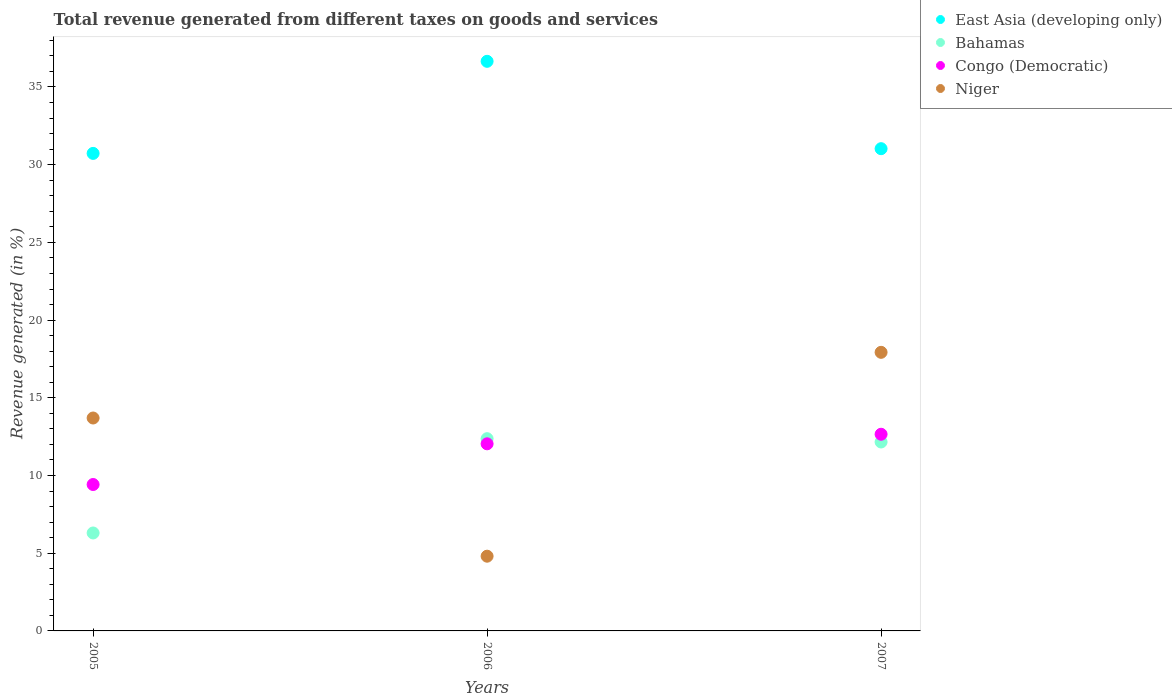What is the total revenue generated in Congo (Democratic) in 2005?
Make the answer very short. 9.42. Across all years, what is the maximum total revenue generated in Congo (Democratic)?
Offer a terse response. 12.66. Across all years, what is the minimum total revenue generated in East Asia (developing only)?
Ensure brevity in your answer.  30.73. In which year was the total revenue generated in East Asia (developing only) maximum?
Keep it short and to the point. 2006. In which year was the total revenue generated in Niger minimum?
Offer a terse response. 2006. What is the total total revenue generated in Congo (Democratic) in the graph?
Your response must be concise. 34.12. What is the difference between the total revenue generated in East Asia (developing only) in 2005 and that in 2006?
Offer a terse response. -5.92. What is the difference between the total revenue generated in Congo (Democratic) in 2006 and the total revenue generated in East Asia (developing only) in 2005?
Give a very brief answer. -18.69. What is the average total revenue generated in Bahamas per year?
Keep it short and to the point. 10.28. In the year 2005, what is the difference between the total revenue generated in East Asia (developing only) and total revenue generated in Niger?
Ensure brevity in your answer.  17.03. What is the ratio of the total revenue generated in Bahamas in 2005 to that in 2006?
Offer a very short reply. 0.51. Is the total revenue generated in Niger in 2005 less than that in 2006?
Provide a short and direct response. No. Is the difference between the total revenue generated in East Asia (developing only) in 2005 and 2007 greater than the difference between the total revenue generated in Niger in 2005 and 2007?
Provide a short and direct response. Yes. What is the difference between the highest and the second highest total revenue generated in East Asia (developing only)?
Provide a succinct answer. 5.62. What is the difference between the highest and the lowest total revenue generated in Congo (Democratic)?
Ensure brevity in your answer.  3.23. Is it the case that in every year, the sum of the total revenue generated in Congo (Democratic) and total revenue generated in East Asia (developing only)  is greater than the total revenue generated in Niger?
Offer a terse response. Yes. Is the total revenue generated in Bahamas strictly less than the total revenue generated in Congo (Democratic) over the years?
Give a very brief answer. No. How many years are there in the graph?
Your response must be concise. 3. What is the difference between two consecutive major ticks on the Y-axis?
Your answer should be compact. 5. How are the legend labels stacked?
Your response must be concise. Vertical. What is the title of the graph?
Offer a very short reply. Total revenue generated from different taxes on goods and services. Does "Puerto Rico" appear as one of the legend labels in the graph?
Ensure brevity in your answer.  No. What is the label or title of the X-axis?
Provide a succinct answer. Years. What is the label or title of the Y-axis?
Provide a succinct answer. Revenue generated (in %). What is the Revenue generated (in %) of East Asia (developing only) in 2005?
Give a very brief answer. 30.73. What is the Revenue generated (in %) in Bahamas in 2005?
Provide a succinct answer. 6.3. What is the Revenue generated (in %) in Congo (Democratic) in 2005?
Your answer should be very brief. 9.42. What is the Revenue generated (in %) in Niger in 2005?
Ensure brevity in your answer.  13.7. What is the Revenue generated (in %) of East Asia (developing only) in 2006?
Give a very brief answer. 36.65. What is the Revenue generated (in %) of Bahamas in 2006?
Your answer should be very brief. 12.37. What is the Revenue generated (in %) in Congo (Democratic) in 2006?
Offer a terse response. 12.04. What is the Revenue generated (in %) of Niger in 2006?
Your answer should be compact. 4.81. What is the Revenue generated (in %) of East Asia (developing only) in 2007?
Offer a very short reply. 31.03. What is the Revenue generated (in %) of Bahamas in 2007?
Offer a very short reply. 12.16. What is the Revenue generated (in %) in Congo (Democratic) in 2007?
Make the answer very short. 12.66. What is the Revenue generated (in %) in Niger in 2007?
Your response must be concise. 17.93. Across all years, what is the maximum Revenue generated (in %) of East Asia (developing only)?
Ensure brevity in your answer.  36.65. Across all years, what is the maximum Revenue generated (in %) in Bahamas?
Ensure brevity in your answer.  12.37. Across all years, what is the maximum Revenue generated (in %) of Congo (Democratic)?
Ensure brevity in your answer.  12.66. Across all years, what is the maximum Revenue generated (in %) in Niger?
Provide a short and direct response. 17.93. Across all years, what is the minimum Revenue generated (in %) in East Asia (developing only)?
Ensure brevity in your answer.  30.73. Across all years, what is the minimum Revenue generated (in %) in Bahamas?
Your response must be concise. 6.3. Across all years, what is the minimum Revenue generated (in %) in Congo (Democratic)?
Provide a succinct answer. 9.42. Across all years, what is the minimum Revenue generated (in %) of Niger?
Your answer should be very brief. 4.81. What is the total Revenue generated (in %) of East Asia (developing only) in the graph?
Your answer should be compact. 98.41. What is the total Revenue generated (in %) of Bahamas in the graph?
Your answer should be very brief. 30.83. What is the total Revenue generated (in %) of Congo (Democratic) in the graph?
Provide a succinct answer. 34.12. What is the total Revenue generated (in %) in Niger in the graph?
Keep it short and to the point. 36.44. What is the difference between the Revenue generated (in %) in East Asia (developing only) in 2005 and that in 2006?
Provide a succinct answer. -5.92. What is the difference between the Revenue generated (in %) in Bahamas in 2005 and that in 2006?
Offer a terse response. -6.07. What is the difference between the Revenue generated (in %) in Congo (Democratic) in 2005 and that in 2006?
Your answer should be compact. -2.62. What is the difference between the Revenue generated (in %) of Niger in 2005 and that in 2006?
Ensure brevity in your answer.  8.89. What is the difference between the Revenue generated (in %) of East Asia (developing only) in 2005 and that in 2007?
Your answer should be very brief. -0.3. What is the difference between the Revenue generated (in %) of Bahamas in 2005 and that in 2007?
Provide a short and direct response. -5.85. What is the difference between the Revenue generated (in %) of Congo (Democratic) in 2005 and that in 2007?
Your answer should be very brief. -3.23. What is the difference between the Revenue generated (in %) in Niger in 2005 and that in 2007?
Provide a short and direct response. -4.23. What is the difference between the Revenue generated (in %) of East Asia (developing only) in 2006 and that in 2007?
Offer a terse response. 5.62. What is the difference between the Revenue generated (in %) in Bahamas in 2006 and that in 2007?
Your answer should be compact. 0.21. What is the difference between the Revenue generated (in %) of Congo (Democratic) in 2006 and that in 2007?
Your answer should be very brief. -0.62. What is the difference between the Revenue generated (in %) of Niger in 2006 and that in 2007?
Your answer should be compact. -13.12. What is the difference between the Revenue generated (in %) in East Asia (developing only) in 2005 and the Revenue generated (in %) in Bahamas in 2006?
Keep it short and to the point. 18.36. What is the difference between the Revenue generated (in %) in East Asia (developing only) in 2005 and the Revenue generated (in %) in Congo (Democratic) in 2006?
Offer a very short reply. 18.69. What is the difference between the Revenue generated (in %) in East Asia (developing only) in 2005 and the Revenue generated (in %) in Niger in 2006?
Make the answer very short. 25.92. What is the difference between the Revenue generated (in %) in Bahamas in 2005 and the Revenue generated (in %) in Congo (Democratic) in 2006?
Your response must be concise. -5.74. What is the difference between the Revenue generated (in %) in Bahamas in 2005 and the Revenue generated (in %) in Niger in 2006?
Your answer should be compact. 1.49. What is the difference between the Revenue generated (in %) in Congo (Democratic) in 2005 and the Revenue generated (in %) in Niger in 2006?
Provide a succinct answer. 4.61. What is the difference between the Revenue generated (in %) of East Asia (developing only) in 2005 and the Revenue generated (in %) of Bahamas in 2007?
Keep it short and to the point. 18.57. What is the difference between the Revenue generated (in %) of East Asia (developing only) in 2005 and the Revenue generated (in %) of Congo (Democratic) in 2007?
Give a very brief answer. 18.07. What is the difference between the Revenue generated (in %) of East Asia (developing only) in 2005 and the Revenue generated (in %) of Niger in 2007?
Your answer should be compact. 12.8. What is the difference between the Revenue generated (in %) of Bahamas in 2005 and the Revenue generated (in %) of Congo (Democratic) in 2007?
Offer a terse response. -6.35. What is the difference between the Revenue generated (in %) in Bahamas in 2005 and the Revenue generated (in %) in Niger in 2007?
Give a very brief answer. -11.62. What is the difference between the Revenue generated (in %) of Congo (Democratic) in 2005 and the Revenue generated (in %) of Niger in 2007?
Provide a succinct answer. -8.51. What is the difference between the Revenue generated (in %) in East Asia (developing only) in 2006 and the Revenue generated (in %) in Bahamas in 2007?
Keep it short and to the point. 24.5. What is the difference between the Revenue generated (in %) of East Asia (developing only) in 2006 and the Revenue generated (in %) of Congo (Democratic) in 2007?
Your answer should be very brief. 24. What is the difference between the Revenue generated (in %) in East Asia (developing only) in 2006 and the Revenue generated (in %) in Niger in 2007?
Provide a short and direct response. 18.73. What is the difference between the Revenue generated (in %) of Bahamas in 2006 and the Revenue generated (in %) of Congo (Democratic) in 2007?
Offer a terse response. -0.29. What is the difference between the Revenue generated (in %) in Bahamas in 2006 and the Revenue generated (in %) in Niger in 2007?
Give a very brief answer. -5.56. What is the difference between the Revenue generated (in %) in Congo (Democratic) in 2006 and the Revenue generated (in %) in Niger in 2007?
Make the answer very short. -5.89. What is the average Revenue generated (in %) in East Asia (developing only) per year?
Make the answer very short. 32.8. What is the average Revenue generated (in %) in Bahamas per year?
Your response must be concise. 10.28. What is the average Revenue generated (in %) of Congo (Democratic) per year?
Your response must be concise. 11.37. What is the average Revenue generated (in %) of Niger per year?
Your response must be concise. 12.15. In the year 2005, what is the difference between the Revenue generated (in %) in East Asia (developing only) and Revenue generated (in %) in Bahamas?
Your answer should be compact. 24.42. In the year 2005, what is the difference between the Revenue generated (in %) of East Asia (developing only) and Revenue generated (in %) of Congo (Democratic)?
Give a very brief answer. 21.31. In the year 2005, what is the difference between the Revenue generated (in %) in East Asia (developing only) and Revenue generated (in %) in Niger?
Give a very brief answer. 17.03. In the year 2005, what is the difference between the Revenue generated (in %) of Bahamas and Revenue generated (in %) of Congo (Democratic)?
Offer a very short reply. -3.12. In the year 2005, what is the difference between the Revenue generated (in %) in Bahamas and Revenue generated (in %) in Niger?
Your response must be concise. -7.4. In the year 2005, what is the difference between the Revenue generated (in %) in Congo (Democratic) and Revenue generated (in %) in Niger?
Give a very brief answer. -4.28. In the year 2006, what is the difference between the Revenue generated (in %) in East Asia (developing only) and Revenue generated (in %) in Bahamas?
Keep it short and to the point. 24.28. In the year 2006, what is the difference between the Revenue generated (in %) of East Asia (developing only) and Revenue generated (in %) of Congo (Democratic)?
Provide a short and direct response. 24.61. In the year 2006, what is the difference between the Revenue generated (in %) in East Asia (developing only) and Revenue generated (in %) in Niger?
Keep it short and to the point. 31.84. In the year 2006, what is the difference between the Revenue generated (in %) in Bahamas and Revenue generated (in %) in Congo (Democratic)?
Your response must be concise. 0.33. In the year 2006, what is the difference between the Revenue generated (in %) in Bahamas and Revenue generated (in %) in Niger?
Offer a terse response. 7.56. In the year 2006, what is the difference between the Revenue generated (in %) of Congo (Democratic) and Revenue generated (in %) of Niger?
Your answer should be very brief. 7.23. In the year 2007, what is the difference between the Revenue generated (in %) of East Asia (developing only) and Revenue generated (in %) of Bahamas?
Offer a terse response. 18.87. In the year 2007, what is the difference between the Revenue generated (in %) in East Asia (developing only) and Revenue generated (in %) in Congo (Democratic)?
Your response must be concise. 18.38. In the year 2007, what is the difference between the Revenue generated (in %) in East Asia (developing only) and Revenue generated (in %) in Niger?
Give a very brief answer. 13.1. In the year 2007, what is the difference between the Revenue generated (in %) in Bahamas and Revenue generated (in %) in Congo (Democratic)?
Ensure brevity in your answer.  -0.5. In the year 2007, what is the difference between the Revenue generated (in %) in Bahamas and Revenue generated (in %) in Niger?
Offer a very short reply. -5.77. In the year 2007, what is the difference between the Revenue generated (in %) of Congo (Democratic) and Revenue generated (in %) of Niger?
Give a very brief answer. -5.27. What is the ratio of the Revenue generated (in %) in East Asia (developing only) in 2005 to that in 2006?
Your answer should be compact. 0.84. What is the ratio of the Revenue generated (in %) in Bahamas in 2005 to that in 2006?
Your answer should be compact. 0.51. What is the ratio of the Revenue generated (in %) in Congo (Democratic) in 2005 to that in 2006?
Ensure brevity in your answer.  0.78. What is the ratio of the Revenue generated (in %) of Niger in 2005 to that in 2006?
Your answer should be compact. 2.85. What is the ratio of the Revenue generated (in %) of East Asia (developing only) in 2005 to that in 2007?
Keep it short and to the point. 0.99. What is the ratio of the Revenue generated (in %) of Bahamas in 2005 to that in 2007?
Provide a short and direct response. 0.52. What is the ratio of the Revenue generated (in %) in Congo (Democratic) in 2005 to that in 2007?
Your answer should be compact. 0.74. What is the ratio of the Revenue generated (in %) in Niger in 2005 to that in 2007?
Offer a terse response. 0.76. What is the ratio of the Revenue generated (in %) in East Asia (developing only) in 2006 to that in 2007?
Keep it short and to the point. 1.18. What is the ratio of the Revenue generated (in %) in Bahamas in 2006 to that in 2007?
Offer a terse response. 1.02. What is the ratio of the Revenue generated (in %) in Congo (Democratic) in 2006 to that in 2007?
Ensure brevity in your answer.  0.95. What is the ratio of the Revenue generated (in %) in Niger in 2006 to that in 2007?
Provide a short and direct response. 0.27. What is the difference between the highest and the second highest Revenue generated (in %) of East Asia (developing only)?
Your answer should be compact. 5.62. What is the difference between the highest and the second highest Revenue generated (in %) in Bahamas?
Your response must be concise. 0.21. What is the difference between the highest and the second highest Revenue generated (in %) in Congo (Democratic)?
Give a very brief answer. 0.62. What is the difference between the highest and the second highest Revenue generated (in %) of Niger?
Your answer should be very brief. 4.23. What is the difference between the highest and the lowest Revenue generated (in %) in East Asia (developing only)?
Your answer should be very brief. 5.92. What is the difference between the highest and the lowest Revenue generated (in %) of Bahamas?
Your response must be concise. 6.07. What is the difference between the highest and the lowest Revenue generated (in %) of Congo (Democratic)?
Your answer should be compact. 3.23. What is the difference between the highest and the lowest Revenue generated (in %) of Niger?
Ensure brevity in your answer.  13.12. 